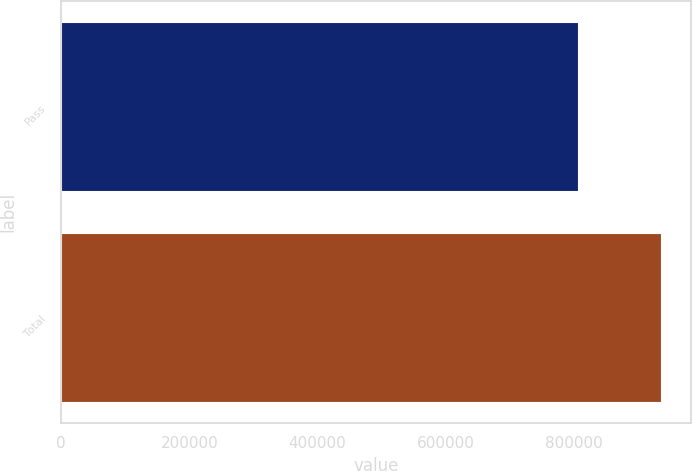Convert chart to OTSL. <chart><loc_0><loc_0><loc_500><loc_500><bar_chart><fcel>Pass<fcel>Total<nl><fcel>806427<fcel>936450<nl></chart> 